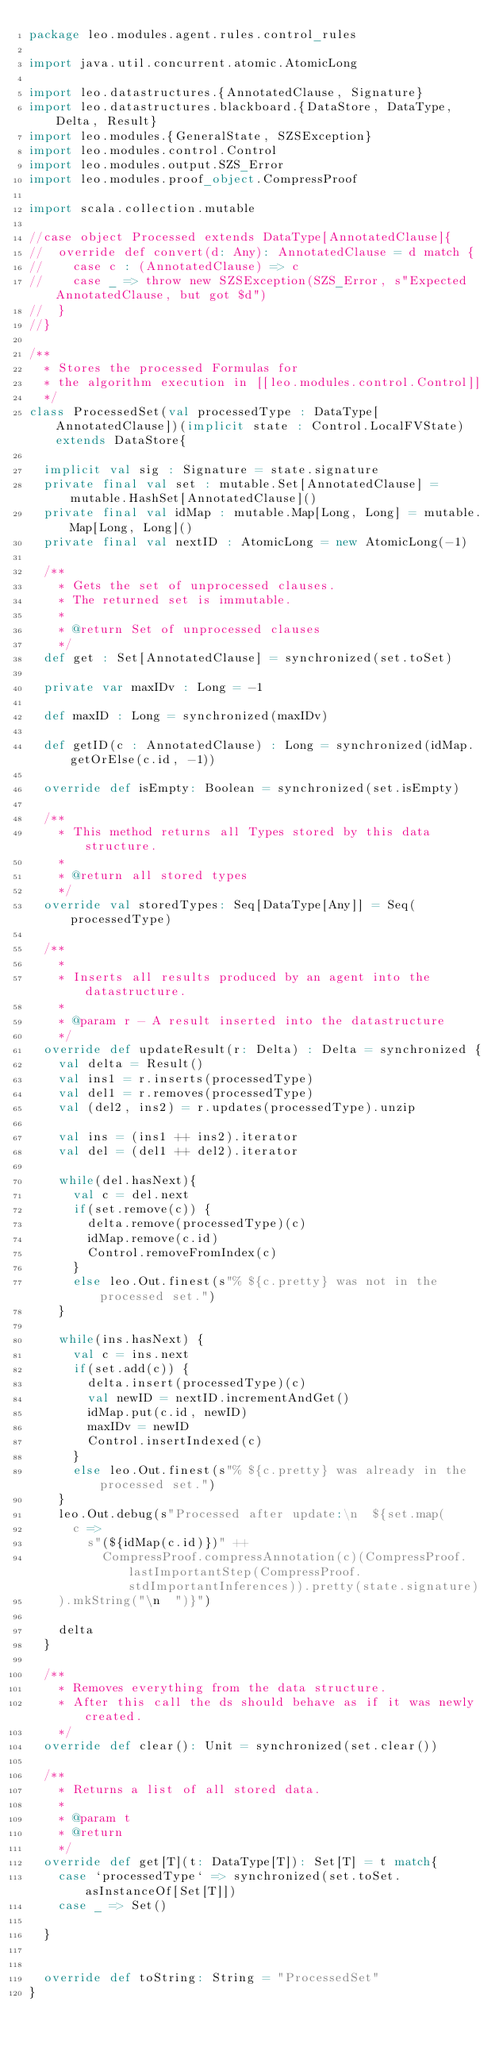<code> <loc_0><loc_0><loc_500><loc_500><_Scala_>package leo.modules.agent.rules.control_rules

import java.util.concurrent.atomic.AtomicLong

import leo.datastructures.{AnnotatedClause, Signature}
import leo.datastructures.blackboard.{DataStore, DataType, Delta, Result}
import leo.modules.{GeneralState, SZSException}
import leo.modules.control.Control
import leo.modules.output.SZS_Error
import leo.modules.proof_object.CompressProof

import scala.collection.mutable

//case object Processed extends DataType[AnnotatedClause]{
//  override def convert(d: Any): AnnotatedClause = d match {
//    case c : (AnnotatedClause) => c
//    case _ => throw new SZSException(SZS_Error, s"Expected AnnotatedClause, but got $d")
//  }
//}

/**
  * Stores the processed Formulas for
  * the algorithm execution in [[leo.modules.control.Control]]
  */
class ProcessedSet(val processedType : DataType[AnnotatedClause])(implicit state : Control.LocalFVState)  extends DataStore{

  implicit val sig : Signature = state.signature
  private final val set : mutable.Set[AnnotatedClause] = mutable.HashSet[AnnotatedClause]()
  private final val idMap : mutable.Map[Long, Long] = mutable.Map[Long, Long]()
  private final val nextID : AtomicLong = new AtomicLong(-1)

  /**
    * Gets the set of unprocessed clauses.
    * The returned set is immutable.
    *
    * @return Set of unprocessed clauses
    */
  def get : Set[AnnotatedClause] = synchronized(set.toSet)

  private var maxIDv : Long = -1

  def maxID : Long = synchronized(maxIDv)

  def getID(c : AnnotatedClause) : Long = synchronized(idMap.getOrElse(c.id, -1))

  override def isEmpty: Boolean = synchronized(set.isEmpty)

  /**
    * This method returns all Types stored by this data structure.
    *
    * @return all stored types
    */
  override val storedTypes: Seq[DataType[Any]] = Seq(processedType)

  /**
    *
    * Inserts all results produced by an agent into the datastructure.
    *
    * @param r - A result inserted into the datastructure
    */
  override def updateResult(r: Delta) : Delta = synchronized {
    val delta = Result()
    val ins1 = r.inserts(processedType)
    val del1 = r.removes(processedType)
    val (del2, ins2) = r.updates(processedType).unzip

    val ins = (ins1 ++ ins2).iterator
    val del = (del1 ++ del2).iterator

    while(del.hasNext){
      val c = del.next
      if(set.remove(c)) {
        delta.remove(processedType)(c)
        idMap.remove(c.id)
        Control.removeFromIndex(c)
      }
      else leo.Out.finest(s"% ${c.pretty} was not in the processed set.")
    }

    while(ins.hasNext) {
      val c = ins.next
      if(set.add(c)) {
        delta.insert(processedType)(c)
        val newID = nextID.incrementAndGet()
        idMap.put(c.id, newID)
        maxIDv = newID
        Control.insertIndexed(c)
      }
      else leo.Out.finest(s"% ${c.pretty} was already in the processed set.")
    }
    leo.Out.debug(s"Processed after update:\n  ${set.map(
      c =>
        s"(${idMap(c.id)})" ++
          CompressProof.compressAnnotation(c)(CompressProof.lastImportantStep(CompressProof.stdImportantInferences)).pretty(state.signature)
    ).mkString("\n  ")}")

    delta
  }

  /**
    * Removes everything from the data structure.
    * After this call the ds should behave as if it was newly created.
    */
  override def clear(): Unit = synchronized(set.clear())

  /**
    * Returns a list of all stored data.
    *
    * @param t
    * @return
    */
  override def get[T](t: DataType[T]): Set[T] = t match{
    case `processedType` => synchronized(set.toSet.asInstanceOf[Set[T]])
    case _ => Set()

  }


  override def toString: String = "ProcessedSet"
}
</code> 